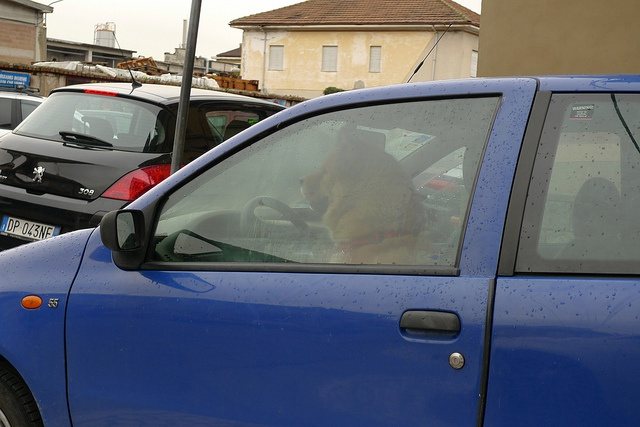Describe the objects in this image and their specific colors. I can see car in black, navy, and gray tones, car in black, darkgray, gray, and lightgray tones, dog in black and gray tones, and car in black, gray, white, and darkgray tones in this image. 